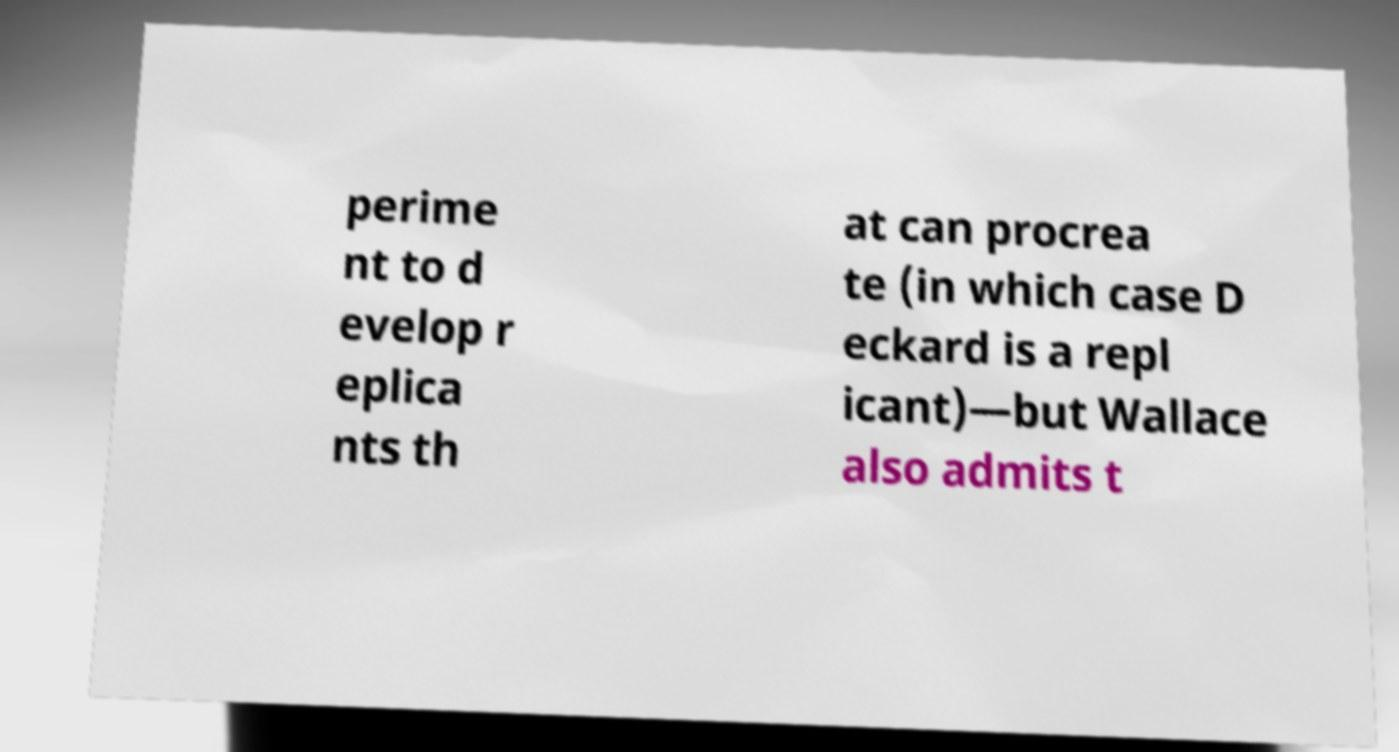There's text embedded in this image that I need extracted. Can you transcribe it verbatim? perime nt to d evelop r eplica nts th at can procrea te (in which case D eckard is a repl icant)—but Wallace also admits t 